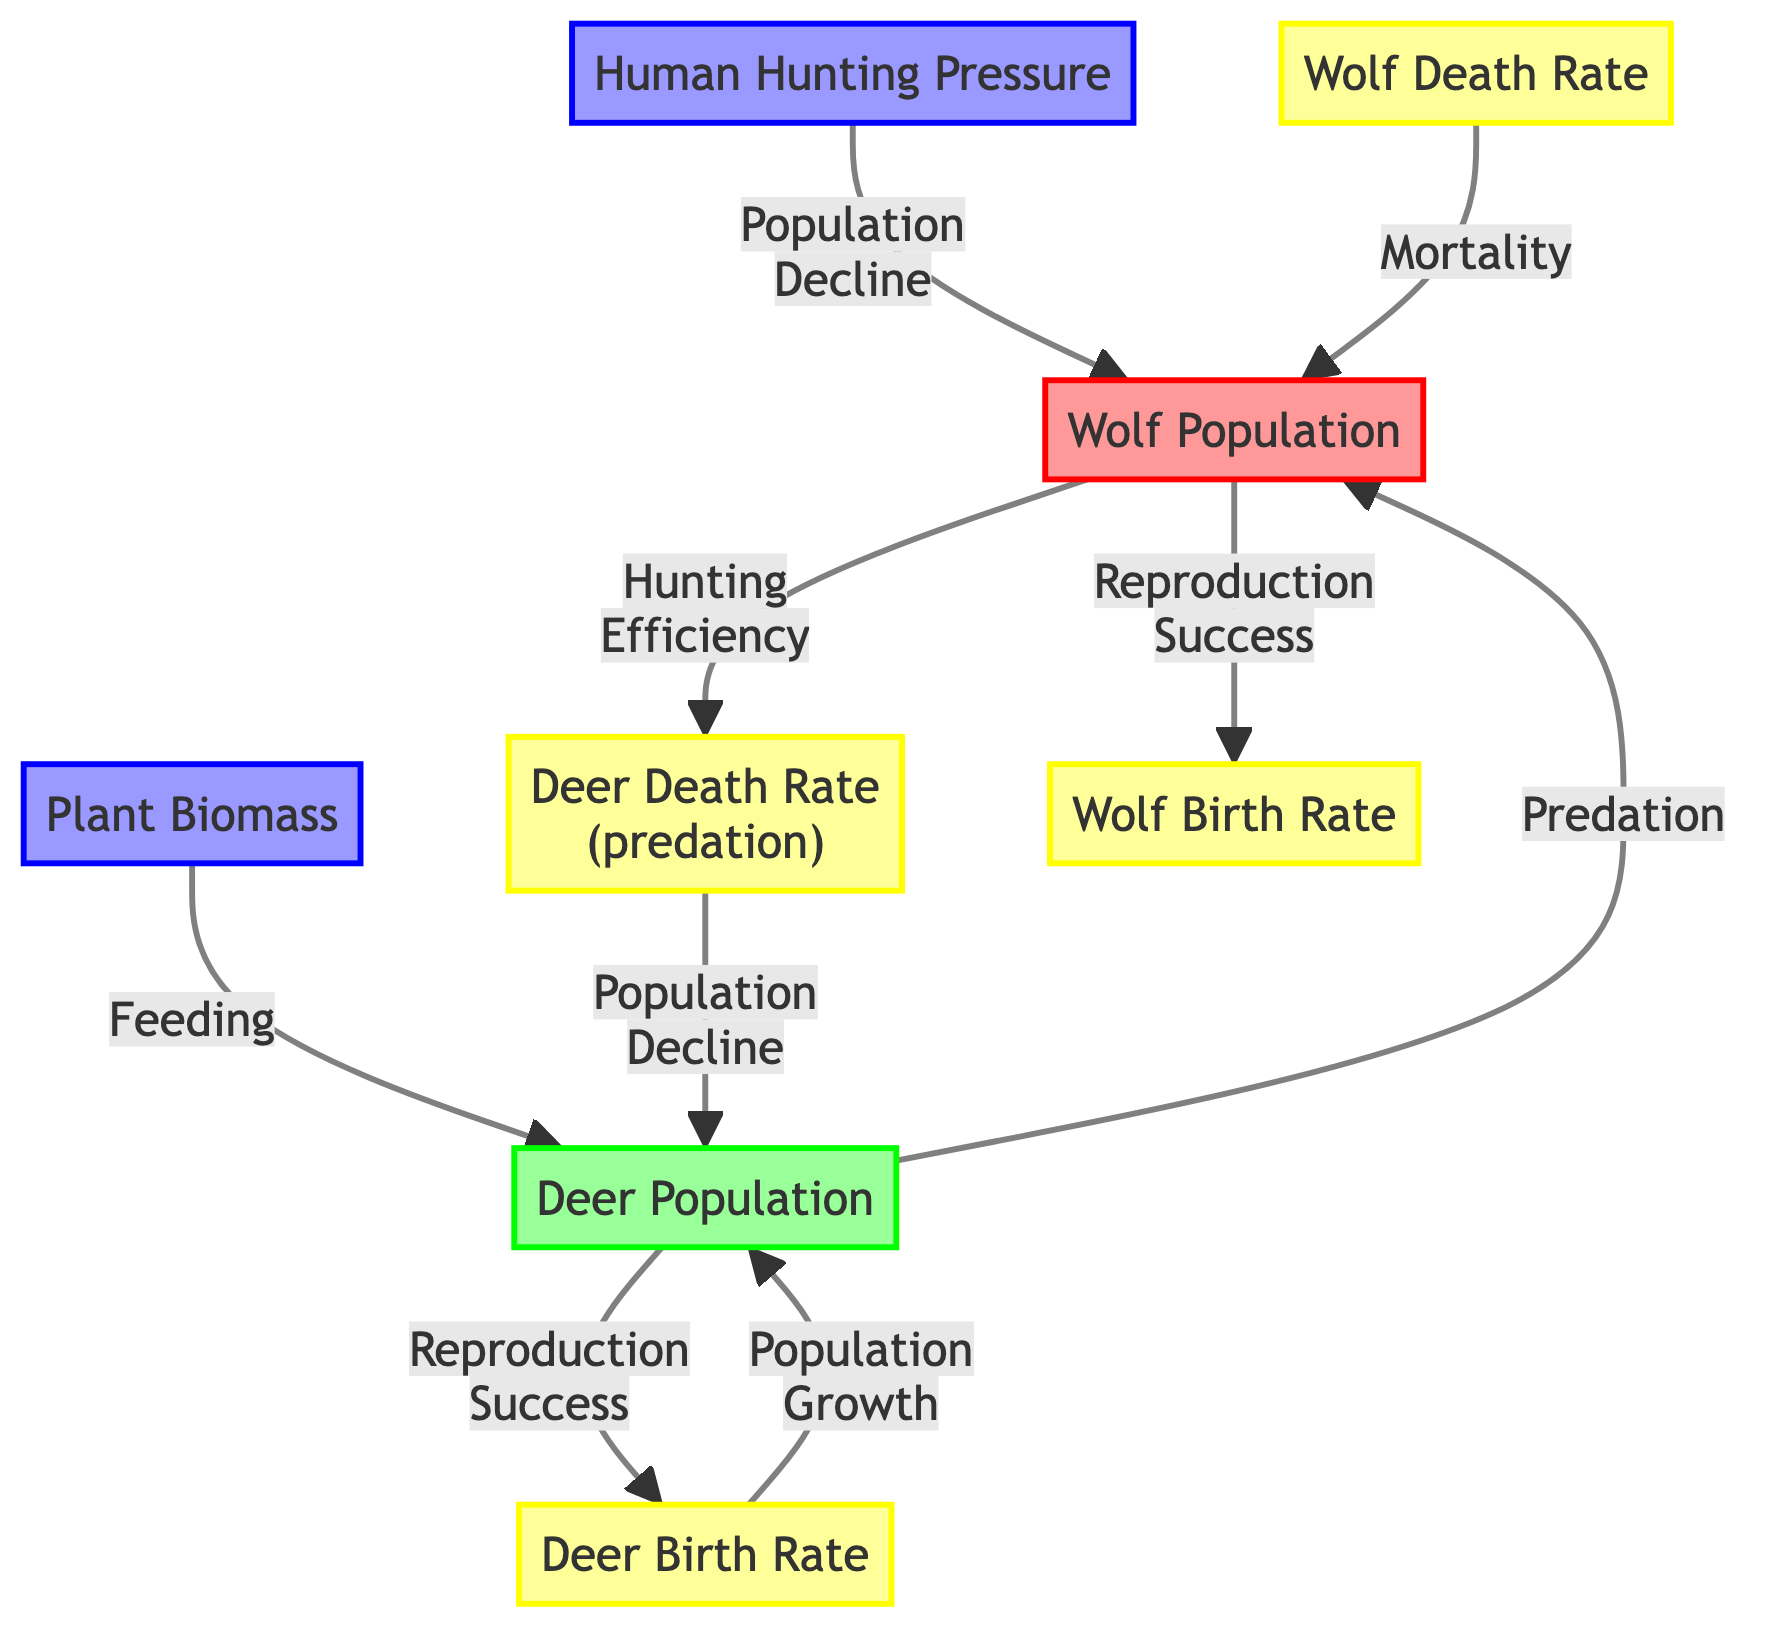What is the name of the predator in this ecosystem? The diagram identifies the predator population as "Wolf Population." This is explicitly labeled in the node representing the predator.
Answer: Wolf Population What is the main source of food supply for the deer? The diagram specifies that "Plant Biomass" serves as the food supply for the deer population, indicated by the arrow pointing from this node to the deer population.
Answer: Plant Biomass How does the wolf population affect the deer population? The relationship in the diagram shows an effect of "Predation" where the wolf population consumes the deer population, thereby impacting its overall numbers.
Answer: Predation What process leads to an increase in the deer population? According to the diagram, the "Deer Birth Rate" influences the growth of the deer population, indicated by the arrow leading to the deer population node.
Answer: Deer Birth Rate What effect does human hunting pressure have on the wolf population? The diagram shows that "Human Hunting Pressure" leads to "Population Decline" in the wolf population, demonstrating its negative effect.
Answer: Population Decline How does the death rate of deer affect their population size? The diagram indicates that the "Deer Death Rate (predation)" leads to a "Population Decline" in the deer population, suggesting a critical connection between predation and deer numbers.
Answer: Population Decline What type of relationship exists between the wolf and deer populations in terms of reproduction? The diagram outlines that both populations affect each other’s reproduction, with arrows indicating “Reproduction Success” coming from both populations, showing a mutual relationship.
Answer: Mutual Relationship What is the outcome if the birth rate of wolves increases? With an increase in the "Wolf Birth Rate," the "Reproduction Success" leads to a growth in the wolf population, suggesting a positive feedback loop affecting their numbers.
Answer: Growth in wolf population What role does feeding play in the dynamics between wolves and deer? The diagram illustrates that the "Feeding" link from "Plant Biomass" to the "Deer Population" signifies how food availability directly supports the deer population, impacting prey dynamics overall.
Answer: Supports deer population dynamics 